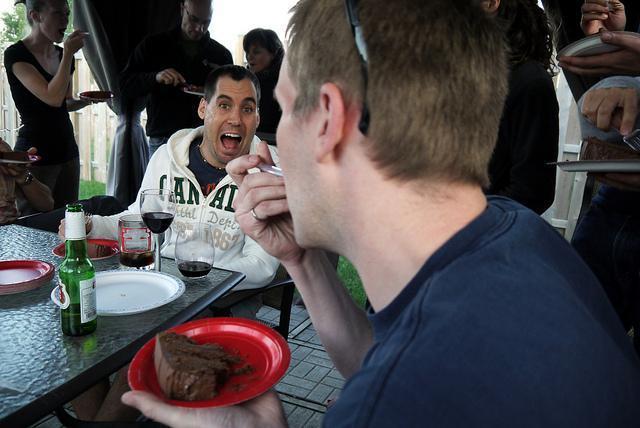How many people are in the picture?
Give a very brief answer. 9. 